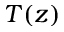Convert formula to latex. <formula><loc_0><loc_0><loc_500><loc_500>T ( z )</formula> 